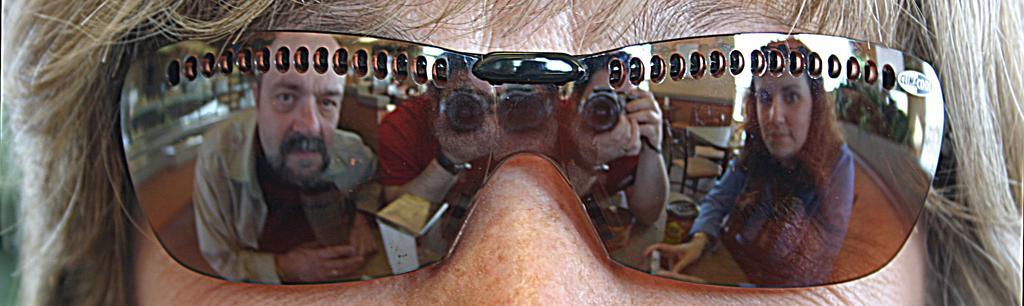Can you describe this image briefly? In the picture we can see a part of the human face with goggles, on the goggles we can see the reflection of man and a woman and one man is capturing the picture with camera. 